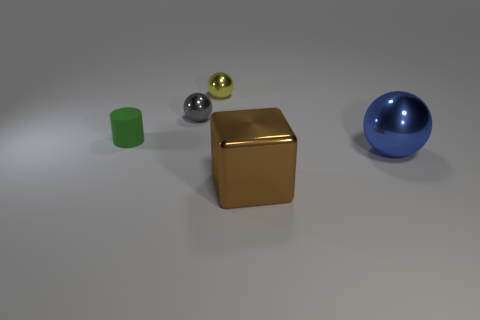Add 1 large cyan balls. How many objects exist? 6 Subtract all blocks. How many objects are left? 4 Subtract all gray metallic objects. Subtract all metal spheres. How many objects are left? 1 Add 5 big blue spheres. How many big blue spheres are left? 6 Add 3 yellow shiny objects. How many yellow shiny objects exist? 4 Subtract 0 purple blocks. How many objects are left? 5 